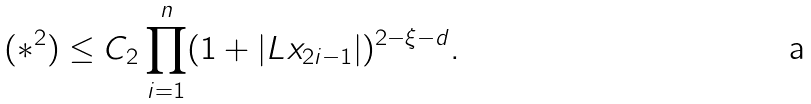<formula> <loc_0><loc_0><loc_500><loc_500>( * ^ { 2 } ) \leq C _ { 2 } \prod _ { i = 1 } ^ { n } ( 1 + | L x _ { 2 i - 1 } | ) ^ { 2 - \xi - d } .</formula> 